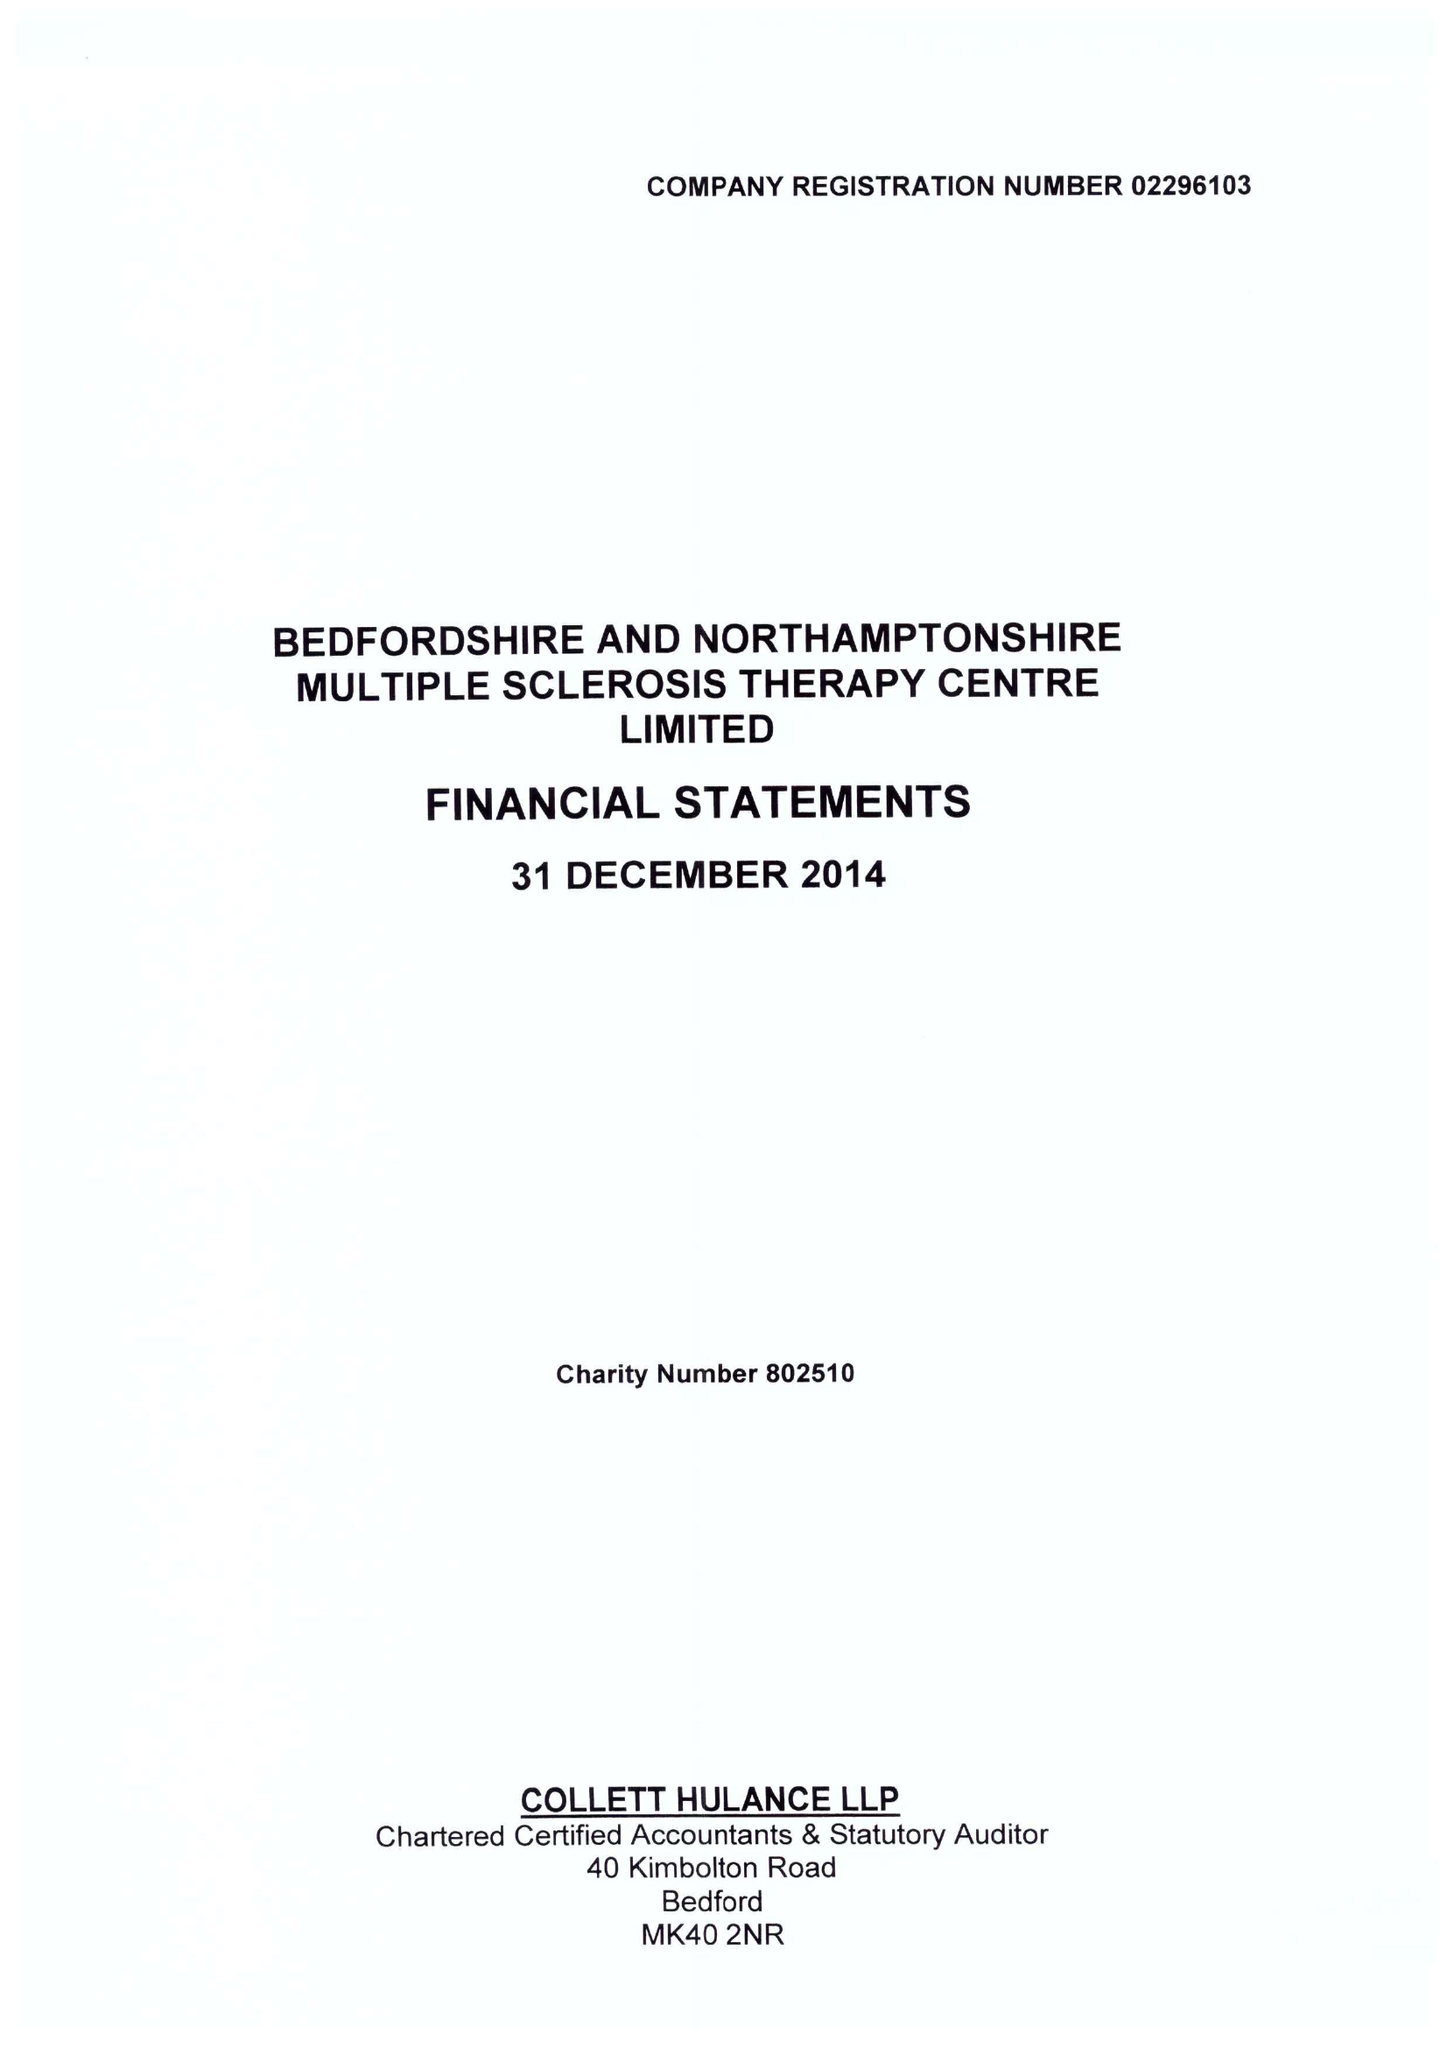What is the value for the spending_annually_in_british_pounds?
Answer the question using a single word or phrase. 381000.00 